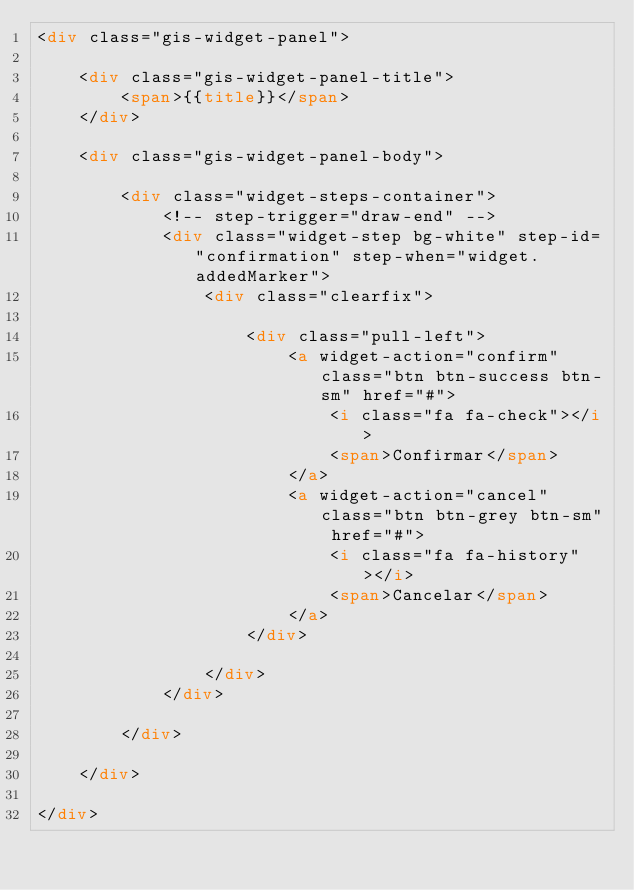Convert code to text. <code><loc_0><loc_0><loc_500><loc_500><_HTML_><div class="gis-widget-panel">

	<div class="gis-widget-panel-title">
		<span>{{title}}</span>
	</div>
	
	<div class="gis-widget-panel-body">
		
		<div class="widget-steps-container">
			<!-- step-trigger="draw-end" -->
			<div class="widget-step bg-white" step-id="confirmation" step-when="widget.addedMarker">
				<div class="clearfix">
					
					<div class="pull-left">
						<a widget-action="confirm" class="btn btn-success btn-sm" href="#">
							<i class="fa fa-check"></i>
							<span>Confirmar</span>
						</a>
						<a widget-action="cancel" class="btn btn-grey btn-sm" href="#">
							<i class="fa fa-history"></i>
							<span>Cancelar</span>
						</a>
					</div>
					
				</div>
			</div>
		
		</div>
	
	</div>
	
</div>
</code> 